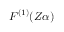<formula> <loc_0><loc_0><loc_500><loc_500>F ^ { ( 1 ) } ( Z \alpha )</formula> 